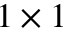<formula> <loc_0><loc_0><loc_500><loc_500>1 \times 1</formula> 